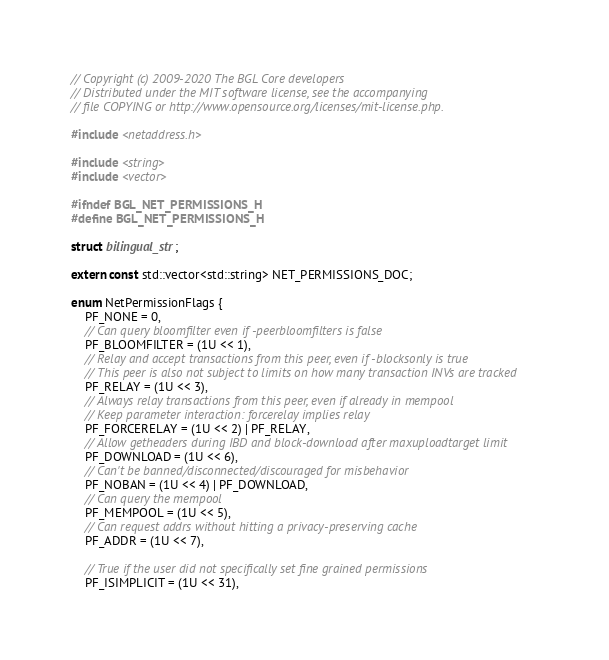Convert code to text. <code><loc_0><loc_0><loc_500><loc_500><_C_>// Copyright (c) 2009-2020 The BGL Core developers
// Distributed under the MIT software license, see the accompanying
// file COPYING or http://www.opensource.org/licenses/mit-license.php.

#include <netaddress.h>

#include <string>
#include <vector>

#ifndef BGL_NET_PERMISSIONS_H
#define BGL_NET_PERMISSIONS_H

struct bilingual_str;

extern const std::vector<std::string> NET_PERMISSIONS_DOC;

enum NetPermissionFlags {
    PF_NONE = 0,
    // Can query bloomfilter even if -peerbloomfilters is false
    PF_BLOOMFILTER = (1U << 1),
    // Relay and accept transactions from this peer, even if -blocksonly is true
    // This peer is also not subject to limits on how many transaction INVs are tracked
    PF_RELAY = (1U << 3),
    // Always relay transactions from this peer, even if already in mempool
    // Keep parameter interaction: forcerelay implies relay
    PF_FORCERELAY = (1U << 2) | PF_RELAY,
    // Allow getheaders during IBD and block-download after maxuploadtarget limit
    PF_DOWNLOAD = (1U << 6),
    // Can't be banned/disconnected/discouraged for misbehavior
    PF_NOBAN = (1U << 4) | PF_DOWNLOAD,
    // Can query the mempool
    PF_MEMPOOL = (1U << 5),
    // Can request addrs without hitting a privacy-preserving cache
    PF_ADDR = (1U << 7),

    // True if the user did not specifically set fine grained permissions
    PF_ISIMPLICIT = (1U << 31),</code> 